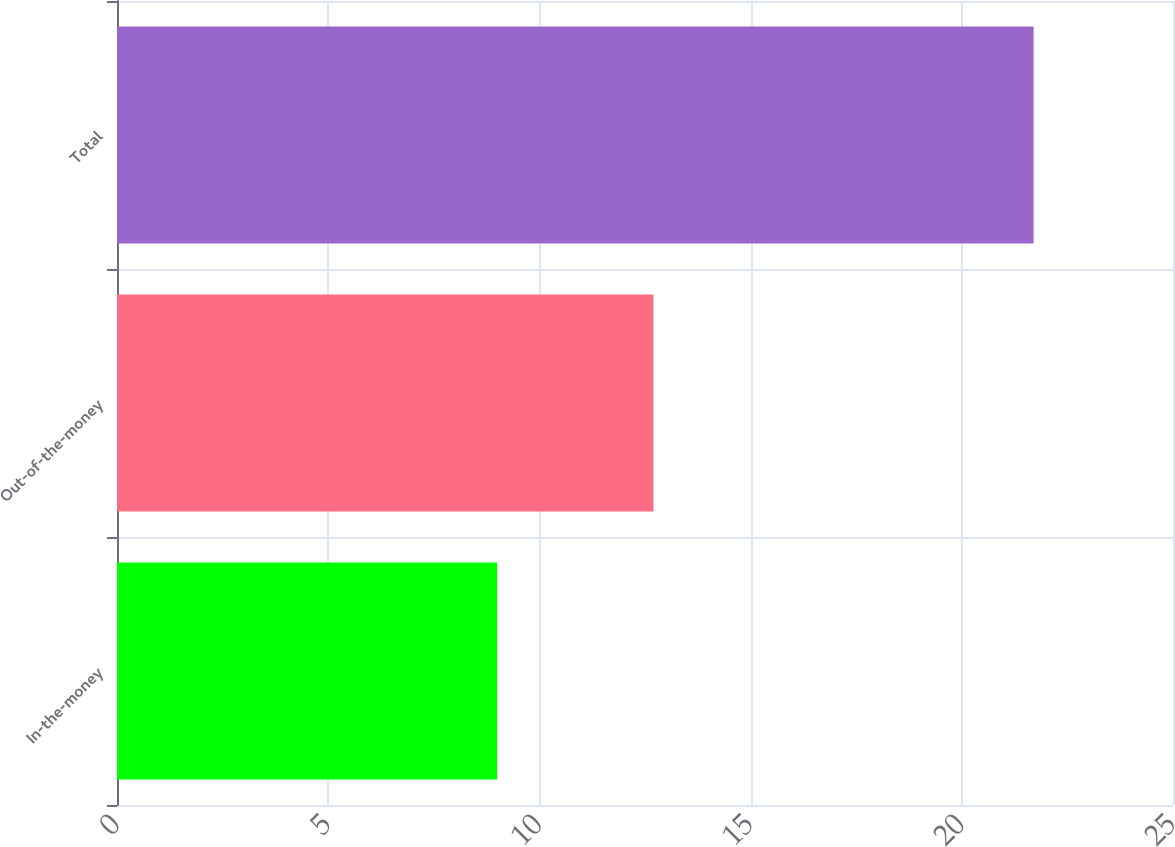Convert chart. <chart><loc_0><loc_0><loc_500><loc_500><bar_chart><fcel>In-the-money<fcel>Out-of-the-money<fcel>Total<nl><fcel>9<fcel>12.7<fcel>21.7<nl></chart> 